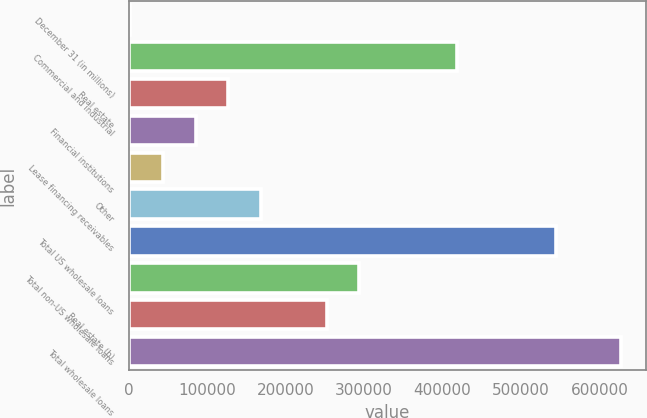<chart> <loc_0><loc_0><loc_500><loc_500><bar_chart><fcel>December 31 (in millions)<fcel>Commercial and industrial<fcel>Real estate<fcel>Financial institutions<fcel>Lease financing receivables<fcel>Other<fcel>Total US wholesale loans<fcel>Total non-US wholesale loans<fcel>Real estate (b)<fcel>Total wholesale loans<nl><fcel>2005<fcel>419148<fcel>127148<fcel>85433.6<fcel>43719.3<fcel>168862<fcel>544291<fcel>294005<fcel>252291<fcel>627720<nl></chart> 